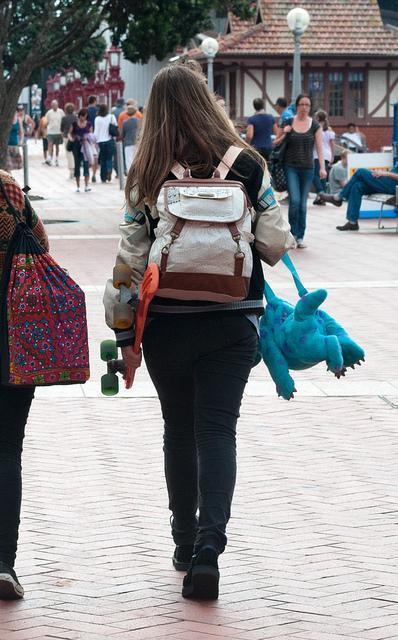How many people are there?
Give a very brief answer. 3. How many backpacks are visible?
Give a very brief answer. 2. How many knives to the left?
Give a very brief answer. 0. 